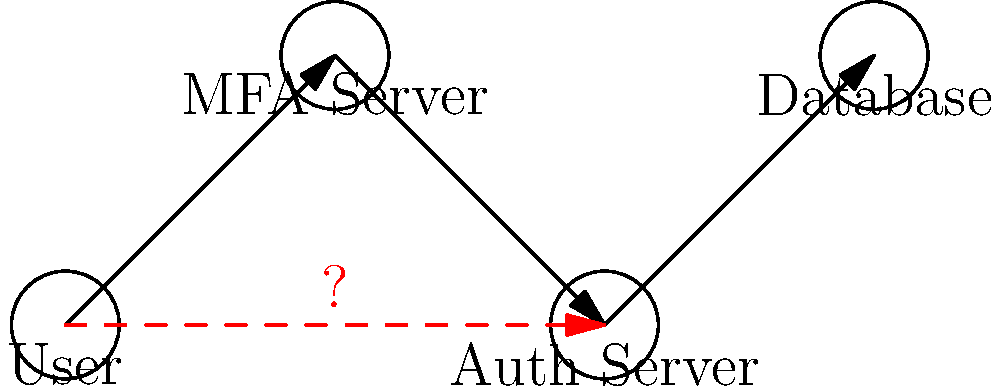In the given network diagram of a multi-factor authentication system, which component represents the most critical vulnerability, and why? To identify the most critical vulnerability in this multi-factor authentication system, let's analyze the diagram step-by-step:

1. The diagram shows four components: User, MFA Server, Auth Server, and Database.

2. The normal flow of authentication is represented by solid arrows:
   User → MFA Server → Auth Server → Database

3. There's an additional dashed red arrow directly connecting the User to the Auth Server, bypassing the MFA Server. This is marked with a red question mark.

4. In a secure multi-factor authentication system, all authentication requests should go through the MFA Server to ensure multiple factors are verified.

5. The dashed red line suggests a potential direct connection between the User and the Auth Server, which could bypass the multi-factor authentication process.

6. This direct connection is the most critical vulnerability because:
   a) It circumvents the additional security layer provided by multi-factor authentication.
   b) It could allow an attacker to authenticate with only a single factor (e.g., password), defeating the purpose of MFA.
   c) It might be exploited through techniques like API manipulation or request forgery.

7. The Auth Server itself becomes the most vulnerable component because it's accepting connections that should be prohibited in a secure MFA setup.

Therefore, the most critical vulnerability is the potential for direct communication between the User and the Auth Server, bypassing the MFA Server. This vulnerability is represented by the Auth Server component in the diagram.
Answer: Auth Server (due to potential MFA bypass) 